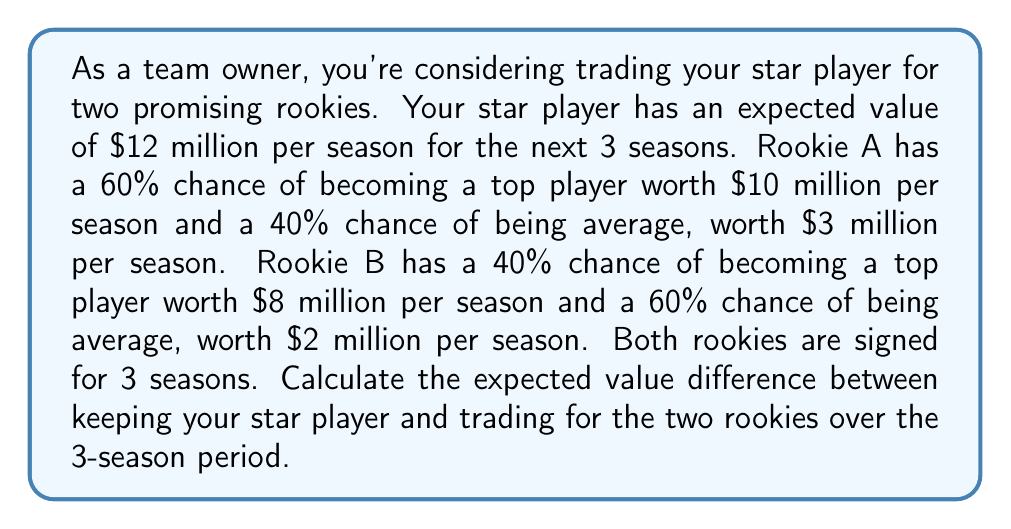Solve this math problem. Let's break this down step-by-step:

1. Calculate the expected value of the star player:
   $$EV_{star} = $12 \text{ million} \times 3 \text{ seasons} = $36 \text{ million}$$

2. Calculate the expected value of Rookie A per season:
   $$EV_A = (0.60 \times $10 \text{ million}) + (0.40 \times $3 \text{ million}) = $6 \text{ million} + $1.2 \text{ million} = $7.2 \text{ million}$$

3. Calculate the expected value of Rookie B per season:
   $$EV_B = (0.40 \times $8 \text{ million}) + (0.60 \times $2 \text{ million}) = $3.2 \text{ million} + $1.2 \text{ million} = $4.4 \text{ million}$$

4. Calculate the combined expected value of both rookies per season:
   $$EV_{rookies} = EV_A + EV_B = $7.2 \text{ million} + $4.4 \text{ million} = $11.6 \text{ million}$$

5. Calculate the total expected value of the rookies over 3 seasons:
   $$EV_{rookies\_total} = $11.6 \text{ million} \times 3 \text{ seasons} = $34.8 \text{ million}$$

6. Calculate the difference in expected value:
   $$EV_{difference} = EV_{star} - EV_{rookies\_total} = $36 \text{ million} - $34.8 \text{ million} = $1.2 \text{ million}$$
Answer: The expected value difference between keeping the star player and trading for the two rookies over the 3-season period is $1.2 million in favor of keeping the star player. 